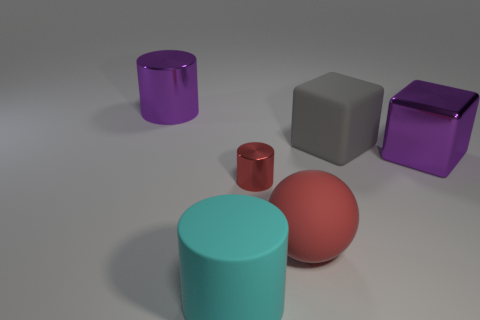Subtract all red cylinders. How many cylinders are left? 2 Add 4 big yellow objects. How many objects exist? 10 Subtract all blocks. How many objects are left? 4 Subtract 1 gray blocks. How many objects are left? 5 Subtract all brown cubes. Subtract all brown cylinders. How many cubes are left? 2 Subtract all brown rubber blocks. Subtract all red balls. How many objects are left? 5 Add 1 purple metal cylinders. How many purple metal cylinders are left? 2 Add 2 big gray rubber objects. How many big gray rubber objects exist? 3 